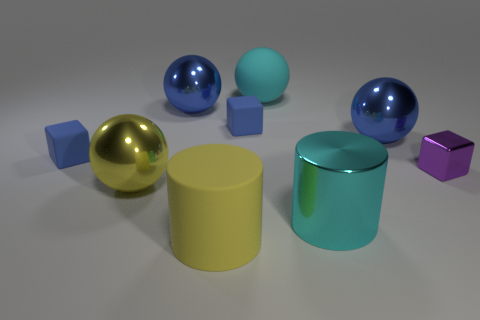Could you guess the purpose of arranging these objects this way? The arrangement of these objects could serve several purposes. One possibility is that this is a composition designed to showcase the different shapes, colors, and material properties in a visually appealing manner, perhaps for a graphic design or art project. Another possibility is that it's part of an experiment or demonstration in lighting and reflection, as the differing surface qualities would interact uniquely with the light. Lastly, this might be a setup for an educational purpose, where the objects are used to teach concepts such as geometry, physics, or color theory. 